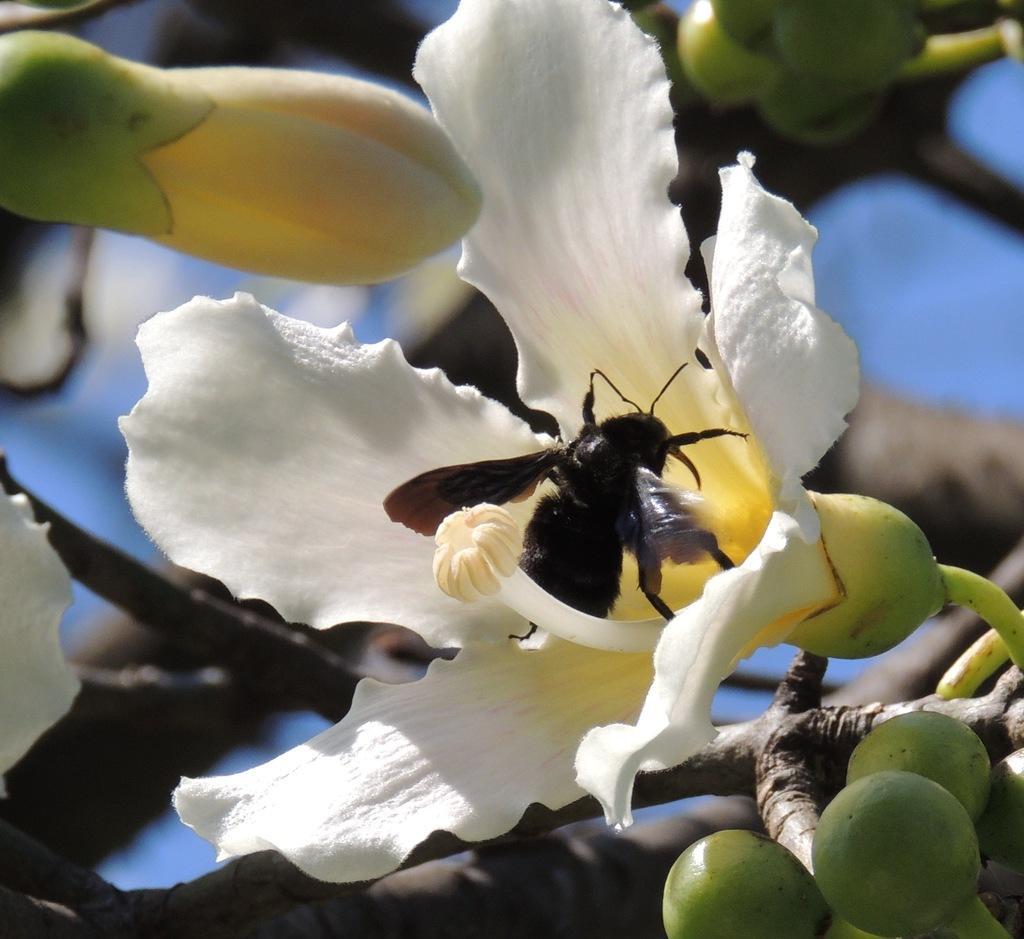Please provide a concise description of this image. In this picture we can see flowers, there is an insect in the middle, we can see a blurry background. 